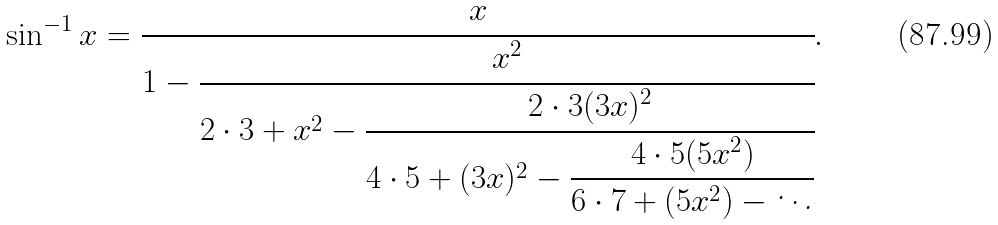<formula> <loc_0><loc_0><loc_500><loc_500>\sin ^ { - 1 } x = { \cfrac { x } { 1 - { \cfrac { x ^ { 2 } } { 2 \cdot 3 + x ^ { 2 } - { \cfrac { 2 \cdot 3 ( 3 x ) ^ { 2 } } { 4 \cdot 5 + ( 3 x ) ^ { 2 } - { \cfrac { 4 \cdot 5 ( 5 x ^ { 2 } ) } { 6 \cdot 7 + ( 5 x ^ { 2 } ) - \ddots } } } } } } } } .</formula> 